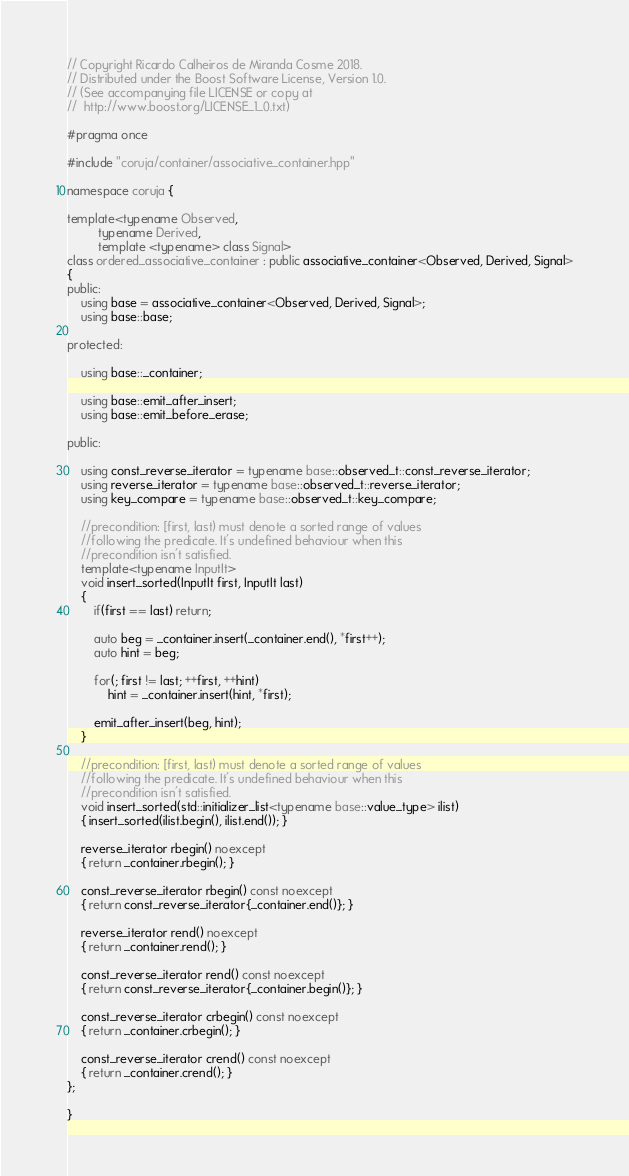<code> <loc_0><loc_0><loc_500><loc_500><_C++_>
// Copyright Ricardo Calheiros de Miranda Cosme 2018.
// Distributed under the Boost Software License, Version 1.0.
// (See accompanying file LICENSE or copy at
//  http://www.boost.org/LICENSE_1_0.txt)

#pragma once

#include "coruja/container/associative_container.hpp"

namespace coruja {

template<typename Observed,
         typename Derived,
         template <typename> class Signal>    
class ordered_associative_container : public associative_container<Observed, Derived, Signal>
{
public:
    using base = associative_container<Observed, Derived, Signal>;
    using base::base;
        
protected:
    
    using base::_container;
    
    using base::emit_after_insert;
    using base::emit_before_erase;
    
public:

    using const_reverse_iterator = typename base::observed_t::const_reverse_iterator;
    using reverse_iterator = typename base::observed_t::reverse_iterator;
    using key_compare = typename base::observed_t::key_compare;
    
    //precondition: [first, last) must denote a sorted range of values
    //following the predicate. It's undefined behaviour when this
    //precondition isn't satisfied.
    template<typename InputIt>
    void insert_sorted(InputIt first, InputIt last)
    {
        if(first == last) return;
        
        auto beg = _container.insert(_container.end(), *first++);
        auto hint = beg;
        
        for(; first != last; ++first, ++hint)
            hint = _container.insert(hint, *first);

        emit_after_insert(beg, hint);
    }
        
    //precondition: [first, last) must denote a sorted range of values
    //following the predicate. It's undefined behaviour when this
    //precondition isn't satisfied.
    void insert_sorted(std::initializer_list<typename base::value_type> ilist)
    { insert_sorted(ilist.begin(), ilist.end()); }
    
    reverse_iterator rbegin() noexcept
    { return _container.rbegin(); }
    
    const_reverse_iterator rbegin() const noexcept
    { return const_reverse_iterator{_container.end()}; }
    
    reverse_iterator rend() noexcept
    { return _container.rend(); }
        
    const_reverse_iterator rend() const noexcept
    { return const_reverse_iterator{_container.begin()}; }
    
    const_reverse_iterator crbegin() const noexcept
    { return _container.crbegin(); }
        
    const_reverse_iterator crend() const noexcept
    { return _container.crend(); }
};
    
}
</code> 